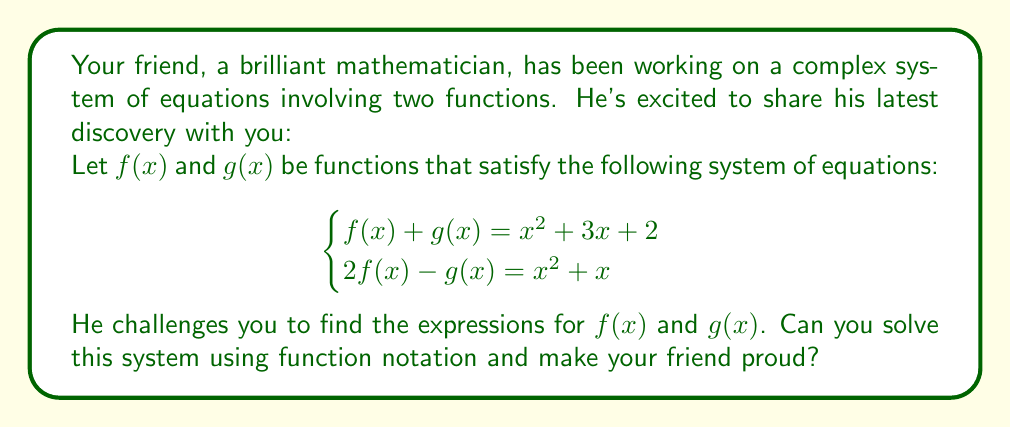Give your solution to this math problem. Let's approach this step-by-step:

1) We have two equations:
   $$f(x) + g(x) = x^2 + 3x + 2 \tag{1}$$
   $$2f(x) - g(x) = x^2 + x \tag{2}$$

2) Our goal is to solve for $f(x)$ and $g(x)$. Let's start by adding equations (1) and (2):
   $$(f(x) + g(x)) + (2f(x) - g(x)) = (x^2 + 3x + 2) + (x^2 + x)$$

3) Simplify:
   $$3f(x) = 2x^2 + 4x + 2$$

4) Divide both sides by 3:
   $$f(x) = \frac{2x^2 + 4x + 2}{3} = \frac{2(x^2 + 2x + 1)}{3}$$

5) Now that we have $f(x)$, let's substitute it into equation (1):
   $$\frac{2(x^2 + 2x + 1)}{3} + g(x) = x^2 + 3x + 2$$

6) Solve for $g(x)$:
   $$g(x) = x^2 + 3x + 2 - \frac{2(x^2 + 2x + 1)}{3}$$
   $$g(x) = \frac{3x^2 + 9x + 6 - 2(x^2 + 2x + 1)}{3}$$
   $$g(x) = \frac{3x^2 + 9x + 6 - 2x^2 - 4x - 2}{3}$$
   $$g(x) = \frac{x^2 + 5x + 4}{3}$$

7) As a final check, we can substitute our expressions for $f(x)$ and $g(x)$ into both original equations to verify that they satisfy the system.
Answer: $f(x) = \frac{2(x^2 + 2x + 1)}{3}$ and $g(x) = \frac{x^2 + 5x + 4}{3}$ 